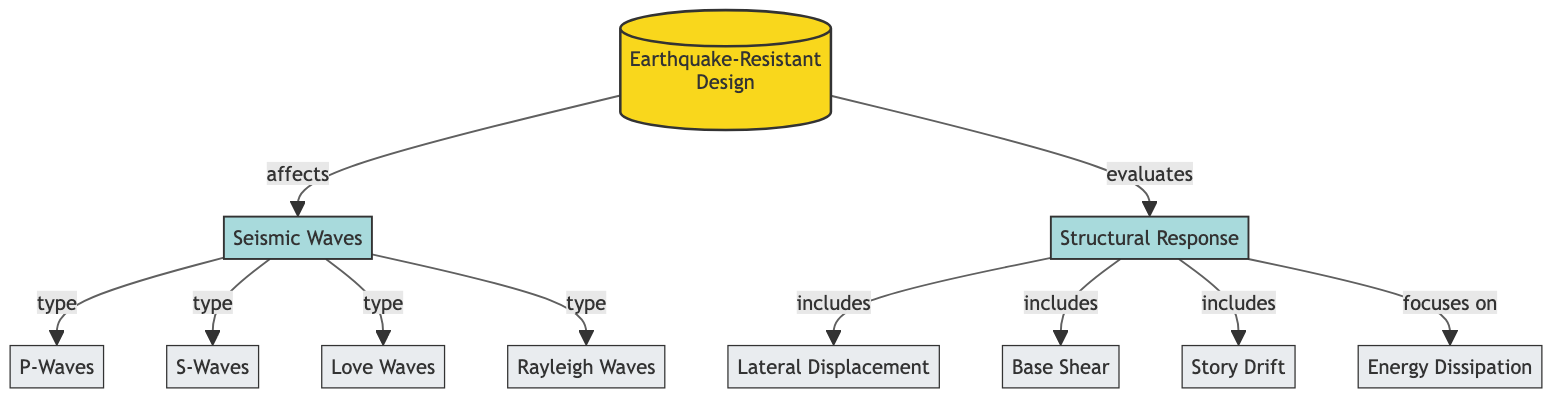What is the main focus of earthquake-resistant design? The diagram indicates that earthquake-resistant design primarily evaluates the structural response, implying that creating designs that can effectively respond to seismic activity is the main goal.
Answer: Structural Response How many types of seismic waves are listed in the diagram? By examining the diagram, it is noted that there are four types of seismic waves (P-Waves, S-Waves, Love Waves, and Rayleigh Waves) mentioned under the "Seismic Waves" node.
Answer: Four Which aspect does the diagram classify as an energy dissipation technique? The diagram shows that energy dissipation is focused on within the structural response node, indicating that it is a crucial principle in managing the impacts of seismic activity on structures.
Answer: Energy Dissipation What is the relationship between 'Seismic Waves' and 'P-Waves'? The diagram clearly demonstrates that P-Waves are categorized as a type of seismic wave, showing a direct connection between these two nodes as a specific classification under the "Seismic Waves" node.
Answer: Type How does 'Structural Response' relate to 'Lateral Displacement'? The diagram indicates that lateral displacement is included within the structural response area, suggesting that it is an essential aspect of how structures react during seismic events.
Answer: Includes Which wave type would arrive first during an earthquake? Analyzing the diagram, P-Waves are known to be the fastest seismic waves, making them the first to arrive during an earthquake, which is recognized commonly in seismic studies.
Answer: P-Waves What does the 'Base Shear' indicate in relation to structural response? The diagram connects base shear directly to the structural response, which indicates that it is a crucial measure of how forces are distributed within a structure during seismic activity.
Answer: Includes How many types of responses are identified in 'Structural Response'? Upon reviewing the diagram, it is clear that there are three specific responses identified (Lateral Displacement, Base Shear, Story Drift) indicated under the "Structural Response" section.
Answer: Three What main factor affects 'Seismic Waves' according to the diagram? The diagram signifies that earthquake-resistant design affects seismic waves, indicating that the design choices play a pivotal role in how these waves are perceived and responded to by structures.
Answer: Affects 